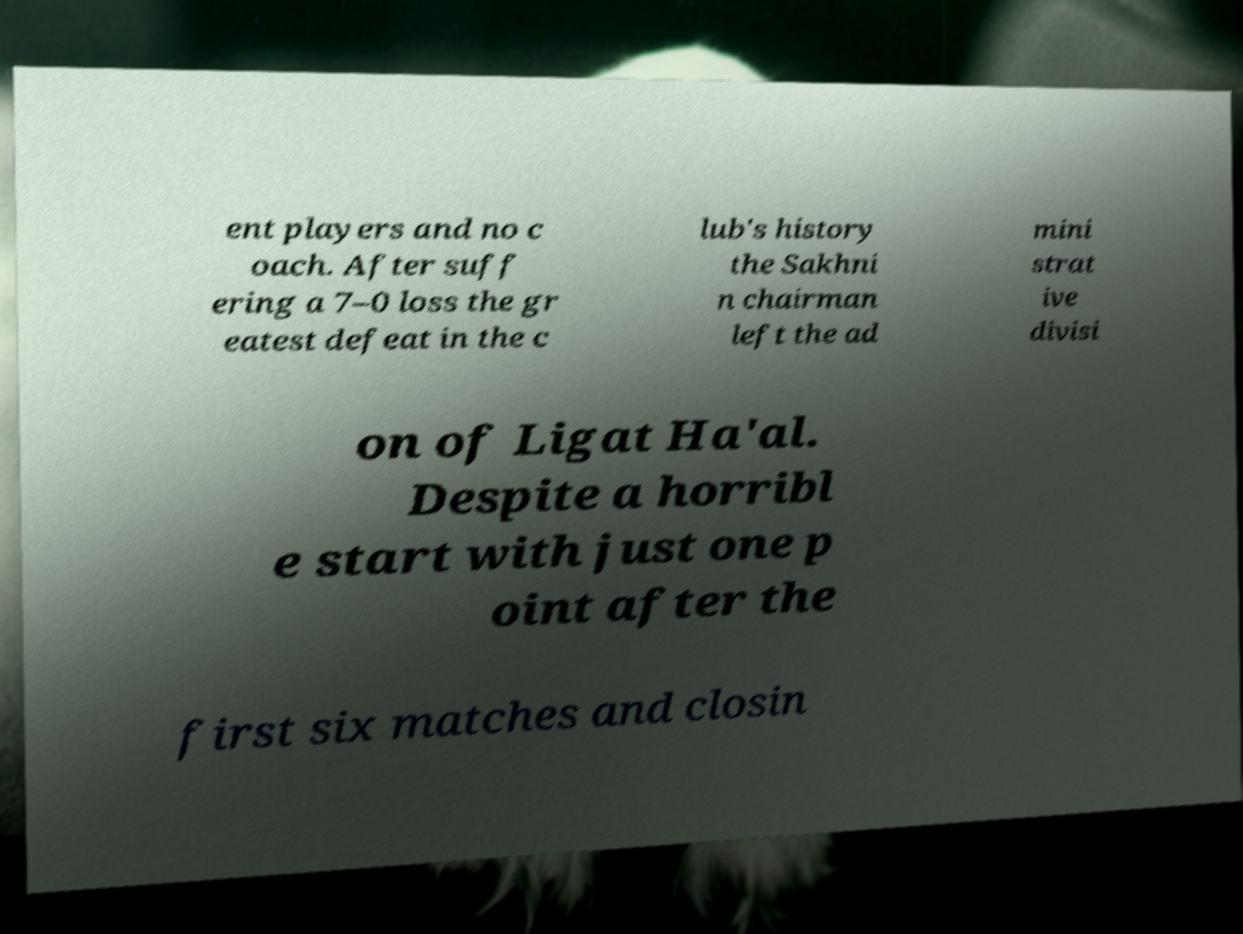Please read and relay the text visible in this image. What does it say? ent players and no c oach. After suff ering a 7–0 loss the gr eatest defeat in the c lub's history the Sakhni n chairman left the ad mini strat ive divisi on of Ligat Ha'al. Despite a horribl e start with just one p oint after the first six matches and closin 